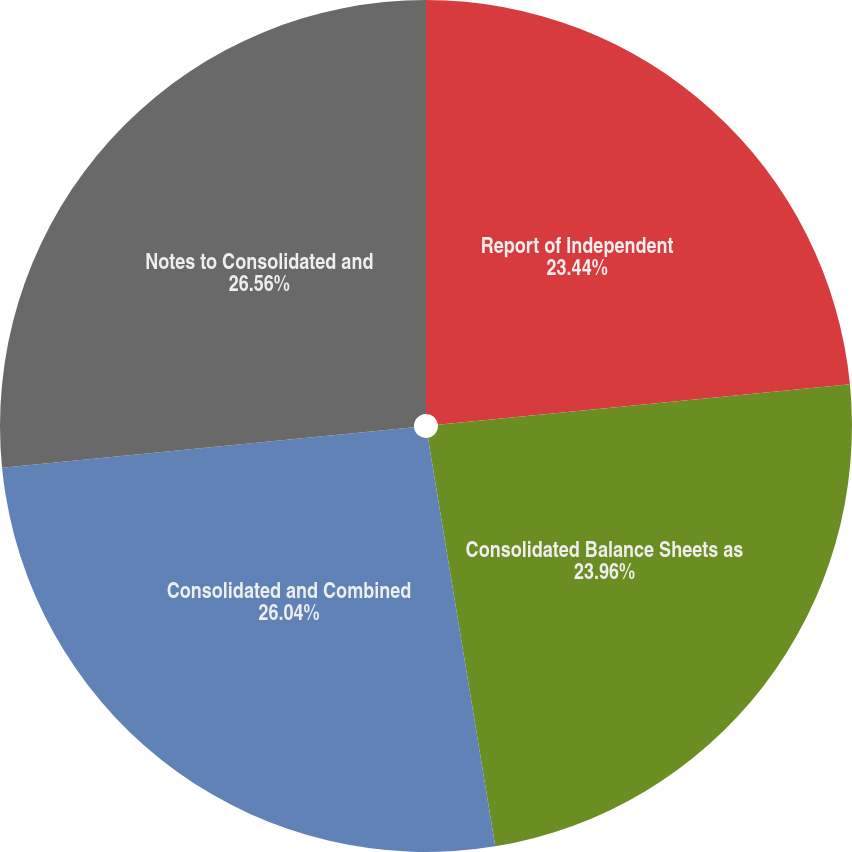Convert chart to OTSL. <chart><loc_0><loc_0><loc_500><loc_500><pie_chart><fcel>Report of Independent<fcel>Consolidated Balance Sheets as<fcel>Consolidated and Combined<fcel>Notes to Consolidated and<nl><fcel>23.44%<fcel>23.96%<fcel>26.04%<fcel>26.56%<nl></chart> 